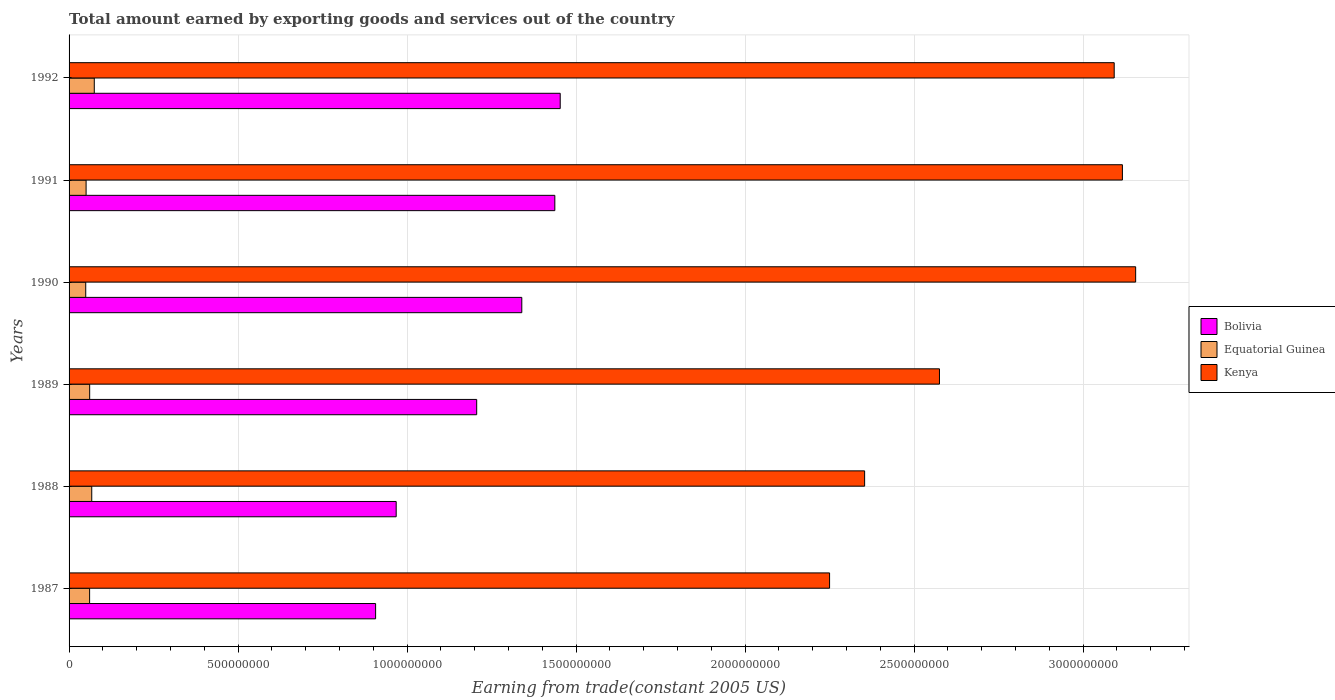Are the number of bars per tick equal to the number of legend labels?
Your response must be concise. Yes. In how many cases, is the number of bars for a given year not equal to the number of legend labels?
Give a very brief answer. 0. What is the total amount earned by exporting goods and services in Kenya in 1992?
Ensure brevity in your answer.  3.09e+09. Across all years, what is the maximum total amount earned by exporting goods and services in Kenya?
Your answer should be compact. 3.16e+09. Across all years, what is the minimum total amount earned by exporting goods and services in Bolivia?
Make the answer very short. 9.07e+08. In which year was the total amount earned by exporting goods and services in Bolivia maximum?
Offer a terse response. 1992. What is the total total amount earned by exporting goods and services in Kenya in the graph?
Provide a short and direct response. 1.65e+1. What is the difference between the total amount earned by exporting goods and services in Equatorial Guinea in 1988 and that in 1989?
Provide a short and direct response. 6.15e+06. What is the difference between the total amount earned by exporting goods and services in Bolivia in 1991 and the total amount earned by exporting goods and services in Kenya in 1989?
Make the answer very short. -1.14e+09. What is the average total amount earned by exporting goods and services in Kenya per year?
Make the answer very short. 2.76e+09. In the year 1991, what is the difference between the total amount earned by exporting goods and services in Bolivia and total amount earned by exporting goods and services in Kenya?
Your answer should be compact. -1.68e+09. What is the ratio of the total amount earned by exporting goods and services in Bolivia in 1987 to that in 1988?
Offer a very short reply. 0.94. Is the total amount earned by exporting goods and services in Kenya in 1989 less than that in 1992?
Offer a terse response. Yes. Is the difference between the total amount earned by exporting goods and services in Bolivia in 1988 and 1990 greater than the difference between the total amount earned by exporting goods and services in Kenya in 1988 and 1990?
Your response must be concise. Yes. What is the difference between the highest and the second highest total amount earned by exporting goods and services in Bolivia?
Provide a succinct answer. 1.60e+07. What is the difference between the highest and the lowest total amount earned by exporting goods and services in Kenya?
Keep it short and to the point. 9.06e+08. Is the sum of the total amount earned by exporting goods and services in Bolivia in 1988 and 1991 greater than the maximum total amount earned by exporting goods and services in Kenya across all years?
Give a very brief answer. No. What does the 1st bar from the top in 1991 represents?
Keep it short and to the point. Kenya. What does the 2nd bar from the bottom in 1992 represents?
Give a very brief answer. Equatorial Guinea. Is it the case that in every year, the sum of the total amount earned by exporting goods and services in Equatorial Guinea and total amount earned by exporting goods and services in Bolivia is greater than the total amount earned by exporting goods and services in Kenya?
Make the answer very short. No. How many bars are there?
Your answer should be very brief. 18. Are all the bars in the graph horizontal?
Keep it short and to the point. Yes. What is the difference between two consecutive major ticks on the X-axis?
Ensure brevity in your answer.  5.00e+08. Does the graph contain any zero values?
Your response must be concise. No. How many legend labels are there?
Keep it short and to the point. 3. What is the title of the graph?
Provide a short and direct response. Total amount earned by exporting goods and services out of the country. What is the label or title of the X-axis?
Your answer should be very brief. Earning from trade(constant 2005 US). What is the label or title of the Y-axis?
Offer a very short reply. Years. What is the Earning from trade(constant 2005 US) in Bolivia in 1987?
Ensure brevity in your answer.  9.07e+08. What is the Earning from trade(constant 2005 US) of Equatorial Guinea in 1987?
Make the answer very short. 6.08e+07. What is the Earning from trade(constant 2005 US) in Kenya in 1987?
Your answer should be compact. 2.25e+09. What is the Earning from trade(constant 2005 US) of Bolivia in 1988?
Make the answer very short. 9.68e+08. What is the Earning from trade(constant 2005 US) in Equatorial Guinea in 1988?
Ensure brevity in your answer.  6.71e+07. What is the Earning from trade(constant 2005 US) in Kenya in 1988?
Your answer should be very brief. 2.35e+09. What is the Earning from trade(constant 2005 US) of Bolivia in 1989?
Ensure brevity in your answer.  1.21e+09. What is the Earning from trade(constant 2005 US) of Equatorial Guinea in 1989?
Your response must be concise. 6.09e+07. What is the Earning from trade(constant 2005 US) of Kenya in 1989?
Give a very brief answer. 2.58e+09. What is the Earning from trade(constant 2005 US) of Bolivia in 1990?
Offer a very short reply. 1.34e+09. What is the Earning from trade(constant 2005 US) of Equatorial Guinea in 1990?
Offer a very short reply. 4.93e+07. What is the Earning from trade(constant 2005 US) in Kenya in 1990?
Offer a terse response. 3.16e+09. What is the Earning from trade(constant 2005 US) in Bolivia in 1991?
Ensure brevity in your answer.  1.44e+09. What is the Earning from trade(constant 2005 US) of Equatorial Guinea in 1991?
Ensure brevity in your answer.  5.03e+07. What is the Earning from trade(constant 2005 US) in Kenya in 1991?
Your answer should be very brief. 3.12e+09. What is the Earning from trade(constant 2005 US) of Bolivia in 1992?
Provide a succinct answer. 1.45e+09. What is the Earning from trade(constant 2005 US) of Equatorial Guinea in 1992?
Your answer should be compact. 7.46e+07. What is the Earning from trade(constant 2005 US) in Kenya in 1992?
Your answer should be very brief. 3.09e+09. Across all years, what is the maximum Earning from trade(constant 2005 US) of Bolivia?
Ensure brevity in your answer.  1.45e+09. Across all years, what is the maximum Earning from trade(constant 2005 US) of Equatorial Guinea?
Your answer should be compact. 7.46e+07. Across all years, what is the maximum Earning from trade(constant 2005 US) in Kenya?
Provide a succinct answer. 3.16e+09. Across all years, what is the minimum Earning from trade(constant 2005 US) of Bolivia?
Give a very brief answer. 9.07e+08. Across all years, what is the minimum Earning from trade(constant 2005 US) in Equatorial Guinea?
Offer a terse response. 4.93e+07. Across all years, what is the minimum Earning from trade(constant 2005 US) in Kenya?
Your response must be concise. 2.25e+09. What is the total Earning from trade(constant 2005 US) of Bolivia in the graph?
Offer a terse response. 7.31e+09. What is the total Earning from trade(constant 2005 US) of Equatorial Guinea in the graph?
Your answer should be very brief. 3.63e+08. What is the total Earning from trade(constant 2005 US) of Kenya in the graph?
Provide a succinct answer. 1.65e+1. What is the difference between the Earning from trade(constant 2005 US) in Bolivia in 1987 and that in 1988?
Ensure brevity in your answer.  -6.08e+07. What is the difference between the Earning from trade(constant 2005 US) of Equatorial Guinea in 1987 and that in 1988?
Make the answer very short. -6.31e+06. What is the difference between the Earning from trade(constant 2005 US) in Kenya in 1987 and that in 1988?
Keep it short and to the point. -1.04e+08. What is the difference between the Earning from trade(constant 2005 US) of Bolivia in 1987 and that in 1989?
Your answer should be very brief. -2.99e+08. What is the difference between the Earning from trade(constant 2005 US) in Equatorial Guinea in 1987 and that in 1989?
Offer a terse response. -1.62e+05. What is the difference between the Earning from trade(constant 2005 US) of Kenya in 1987 and that in 1989?
Provide a succinct answer. -3.25e+08. What is the difference between the Earning from trade(constant 2005 US) in Bolivia in 1987 and that in 1990?
Make the answer very short. -4.33e+08. What is the difference between the Earning from trade(constant 2005 US) in Equatorial Guinea in 1987 and that in 1990?
Keep it short and to the point. 1.15e+07. What is the difference between the Earning from trade(constant 2005 US) of Kenya in 1987 and that in 1990?
Your answer should be compact. -9.06e+08. What is the difference between the Earning from trade(constant 2005 US) of Bolivia in 1987 and that in 1991?
Your response must be concise. -5.30e+08. What is the difference between the Earning from trade(constant 2005 US) of Equatorial Guinea in 1987 and that in 1991?
Make the answer very short. 1.04e+07. What is the difference between the Earning from trade(constant 2005 US) in Kenya in 1987 and that in 1991?
Ensure brevity in your answer.  -8.66e+08. What is the difference between the Earning from trade(constant 2005 US) in Bolivia in 1987 and that in 1992?
Ensure brevity in your answer.  -5.46e+08. What is the difference between the Earning from trade(constant 2005 US) in Equatorial Guinea in 1987 and that in 1992?
Offer a very short reply. -1.38e+07. What is the difference between the Earning from trade(constant 2005 US) in Kenya in 1987 and that in 1992?
Your response must be concise. -8.42e+08. What is the difference between the Earning from trade(constant 2005 US) in Bolivia in 1988 and that in 1989?
Your response must be concise. -2.38e+08. What is the difference between the Earning from trade(constant 2005 US) in Equatorial Guinea in 1988 and that in 1989?
Give a very brief answer. 6.15e+06. What is the difference between the Earning from trade(constant 2005 US) of Kenya in 1988 and that in 1989?
Provide a short and direct response. -2.21e+08. What is the difference between the Earning from trade(constant 2005 US) in Bolivia in 1988 and that in 1990?
Provide a short and direct response. -3.72e+08. What is the difference between the Earning from trade(constant 2005 US) of Equatorial Guinea in 1988 and that in 1990?
Provide a succinct answer. 1.78e+07. What is the difference between the Earning from trade(constant 2005 US) in Kenya in 1988 and that in 1990?
Your answer should be very brief. -8.02e+08. What is the difference between the Earning from trade(constant 2005 US) in Bolivia in 1988 and that in 1991?
Give a very brief answer. -4.69e+08. What is the difference between the Earning from trade(constant 2005 US) of Equatorial Guinea in 1988 and that in 1991?
Give a very brief answer. 1.67e+07. What is the difference between the Earning from trade(constant 2005 US) in Kenya in 1988 and that in 1991?
Offer a very short reply. -7.63e+08. What is the difference between the Earning from trade(constant 2005 US) of Bolivia in 1988 and that in 1992?
Provide a succinct answer. -4.85e+08. What is the difference between the Earning from trade(constant 2005 US) in Equatorial Guinea in 1988 and that in 1992?
Offer a terse response. -7.53e+06. What is the difference between the Earning from trade(constant 2005 US) in Kenya in 1988 and that in 1992?
Ensure brevity in your answer.  -7.38e+08. What is the difference between the Earning from trade(constant 2005 US) in Bolivia in 1989 and that in 1990?
Your answer should be compact. -1.33e+08. What is the difference between the Earning from trade(constant 2005 US) in Equatorial Guinea in 1989 and that in 1990?
Your answer should be very brief. 1.16e+07. What is the difference between the Earning from trade(constant 2005 US) in Kenya in 1989 and that in 1990?
Your answer should be very brief. -5.80e+08. What is the difference between the Earning from trade(constant 2005 US) of Bolivia in 1989 and that in 1991?
Offer a very short reply. -2.31e+08. What is the difference between the Earning from trade(constant 2005 US) in Equatorial Guinea in 1989 and that in 1991?
Your answer should be very brief. 1.06e+07. What is the difference between the Earning from trade(constant 2005 US) in Kenya in 1989 and that in 1991?
Make the answer very short. -5.41e+08. What is the difference between the Earning from trade(constant 2005 US) of Bolivia in 1989 and that in 1992?
Keep it short and to the point. -2.47e+08. What is the difference between the Earning from trade(constant 2005 US) of Equatorial Guinea in 1989 and that in 1992?
Give a very brief answer. -1.37e+07. What is the difference between the Earning from trade(constant 2005 US) of Kenya in 1989 and that in 1992?
Offer a terse response. -5.17e+08. What is the difference between the Earning from trade(constant 2005 US) of Bolivia in 1990 and that in 1991?
Keep it short and to the point. -9.77e+07. What is the difference between the Earning from trade(constant 2005 US) of Equatorial Guinea in 1990 and that in 1991?
Offer a terse response. -1.04e+06. What is the difference between the Earning from trade(constant 2005 US) in Kenya in 1990 and that in 1991?
Your response must be concise. 3.92e+07. What is the difference between the Earning from trade(constant 2005 US) in Bolivia in 1990 and that in 1992?
Offer a very short reply. -1.14e+08. What is the difference between the Earning from trade(constant 2005 US) of Equatorial Guinea in 1990 and that in 1992?
Offer a terse response. -2.53e+07. What is the difference between the Earning from trade(constant 2005 US) of Kenya in 1990 and that in 1992?
Offer a terse response. 6.35e+07. What is the difference between the Earning from trade(constant 2005 US) in Bolivia in 1991 and that in 1992?
Provide a succinct answer. -1.60e+07. What is the difference between the Earning from trade(constant 2005 US) of Equatorial Guinea in 1991 and that in 1992?
Your response must be concise. -2.43e+07. What is the difference between the Earning from trade(constant 2005 US) in Kenya in 1991 and that in 1992?
Your answer should be very brief. 2.43e+07. What is the difference between the Earning from trade(constant 2005 US) of Bolivia in 1987 and the Earning from trade(constant 2005 US) of Equatorial Guinea in 1988?
Provide a short and direct response. 8.40e+08. What is the difference between the Earning from trade(constant 2005 US) of Bolivia in 1987 and the Earning from trade(constant 2005 US) of Kenya in 1988?
Make the answer very short. -1.45e+09. What is the difference between the Earning from trade(constant 2005 US) in Equatorial Guinea in 1987 and the Earning from trade(constant 2005 US) in Kenya in 1988?
Your response must be concise. -2.29e+09. What is the difference between the Earning from trade(constant 2005 US) in Bolivia in 1987 and the Earning from trade(constant 2005 US) in Equatorial Guinea in 1989?
Your answer should be compact. 8.46e+08. What is the difference between the Earning from trade(constant 2005 US) of Bolivia in 1987 and the Earning from trade(constant 2005 US) of Kenya in 1989?
Your answer should be compact. -1.67e+09. What is the difference between the Earning from trade(constant 2005 US) in Equatorial Guinea in 1987 and the Earning from trade(constant 2005 US) in Kenya in 1989?
Your response must be concise. -2.51e+09. What is the difference between the Earning from trade(constant 2005 US) of Bolivia in 1987 and the Earning from trade(constant 2005 US) of Equatorial Guinea in 1990?
Give a very brief answer. 8.58e+08. What is the difference between the Earning from trade(constant 2005 US) in Bolivia in 1987 and the Earning from trade(constant 2005 US) in Kenya in 1990?
Provide a succinct answer. -2.25e+09. What is the difference between the Earning from trade(constant 2005 US) of Equatorial Guinea in 1987 and the Earning from trade(constant 2005 US) of Kenya in 1990?
Your answer should be very brief. -3.09e+09. What is the difference between the Earning from trade(constant 2005 US) in Bolivia in 1987 and the Earning from trade(constant 2005 US) in Equatorial Guinea in 1991?
Your answer should be compact. 8.57e+08. What is the difference between the Earning from trade(constant 2005 US) in Bolivia in 1987 and the Earning from trade(constant 2005 US) in Kenya in 1991?
Your answer should be compact. -2.21e+09. What is the difference between the Earning from trade(constant 2005 US) in Equatorial Guinea in 1987 and the Earning from trade(constant 2005 US) in Kenya in 1991?
Your answer should be very brief. -3.06e+09. What is the difference between the Earning from trade(constant 2005 US) of Bolivia in 1987 and the Earning from trade(constant 2005 US) of Equatorial Guinea in 1992?
Offer a terse response. 8.32e+08. What is the difference between the Earning from trade(constant 2005 US) in Bolivia in 1987 and the Earning from trade(constant 2005 US) in Kenya in 1992?
Offer a terse response. -2.19e+09. What is the difference between the Earning from trade(constant 2005 US) in Equatorial Guinea in 1987 and the Earning from trade(constant 2005 US) in Kenya in 1992?
Offer a terse response. -3.03e+09. What is the difference between the Earning from trade(constant 2005 US) of Bolivia in 1988 and the Earning from trade(constant 2005 US) of Equatorial Guinea in 1989?
Provide a short and direct response. 9.07e+08. What is the difference between the Earning from trade(constant 2005 US) of Bolivia in 1988 and the Earning from trade(constant 2005 US) of Kenya in 1989?
Your answer should be very brief. -1.61e+09. What is the difference between the Earning from trade(constant 2005 US) of Equatorial Guinea in 1988 and the Earning from trade(constant 2005 US) of Kenya in 1989?
Provide a short and direct response. -2.51e+09. What is the difference between the Earning from trade(constant 2005 US) in Bolivia in 1988 and the Earning from trade(constant 2005 US) in Equatorial Guinea in 1990?
Give a very brief answer. 9.18e+08. What is the difference between the Earning from trade(constant 2005 US) of Bolivia in 1988 and the Earning from trade(constant 2005 US) of Kenya in 1990?
Your answer should be compact. -2.19e+09. What is the difference between the Earning from trade(constant 2005 US) of Equatorial Guinea in 1988 and the Earning from trade(constant 2005 US) of Kenya in 1990?
Provide a short and direct response. -3.09e+09. What is the difference between the Earning from trade(constant 2005 US) in Bolivia in 1988 and the Earning from trade(constant 2005 US) in Equatorial Guinea in 1991?
Your response must be concise. 9.17e+08. What is the difference between the Earning from trade(constant 2005 US) of Bolivia in 1988 and the Earning from trade(constant 2005 US) of Kenya in 1991?
Your answer should be compact. -2.15e+09. What is the difference between the Earning from trade(constant 2005 US) of Equatorial Guinea in 1988 and the Earning from trade(constant 2005 US) of Kenya in 1991?
Provide a short and direct response. -3.05e+09. What is the difference between the Earning from trade(constant 2005 US) of Bolivia in 1988 and the Earning from trade(constant 2005 US) of Equatorial Guinea in 1992?
Provide a succinct answer. 8.93e+08. What is the difference between the Earning from trade(constant 2005 US) in Bolivia in 1988 and the Earning from trade(constant 2005 US) in Kenya in 1992?
Keep it short and to the point. -2.12e+09. What is the difference between the Earning from trade(constant 2005 US) in Equatorial Guinea in 1988 and the Earning from trade(constant 2005 US) in Kenya in 1992?
Your response must be concise. -3.03e+09. What is the difference between the Earning from trade(constant 2005 US) in Bolivia in 1989 and the Earning from trade(constant 2005 US) in Equatorial Guinea in 1990?
Offer a terse response. 1.16e+09. What is the difference between the Earning from trade(constant 2005 US) of Bolivia in 1989 and the Earning from trade(constant 2005 US) of Kenya in 1990?
Your answer should be very brief. -1.95e+09. What is the difference between the Earning from trade(constant 2005 US) in Equatorial Guinea in 1989 and the Earning from trade(constant 2005 US) in Kenya in 1990?
Provide a short and direct response. -3.09e+09. What is the difference between the Earning from trade(constant 2005 US) of Bolivia in 1989 and the Earning from trade(constant 2005 US) of Equatorial Guinea in 1991?
Provide a short and direct response. 1.16e+09. What is the difference between the Earning from trade(constant 2005 US) of Bolivia in 1989 and the Earning from trade(constant 2005 US) of Kenya in 1991?
Give a very brief answer. -1.91e+09. What is the difference between the Earning from trade(constant 2005 US) in Equatorial Guinea in 1989 and the Earning from trade(constant 2005 US) in Kenya in 1991?
Ensure brevity in your answer.  -3.06e+09. What is the difference between the Earning from trade(constant 2005 US) in Bolivia in 1989 and the Earning from trade(constant 2005 US) in Equatorial Guinea in 1992?
Keep it short and to the point. 1.13e+09. What is the difference between the Earning from trade(constant 2005 US) in Bolivia in 1989 and the Earning from trade(constant 2005 US) in Kenya in 1992?
Provide a succinct answer. -1.89e+09. What is the difference between the Earning from trade(constant 2005 US) in Equatorial Guinea in 1989 and the Earning from trade(constant 2005 US) in Kenya in 1992?
Your answer should be very brief. -3.03e+09. What is the difference between the Earning from trade(constant 2005 US) in Bolivia in 1990 and the Earning from trade(constant 2005 US) in Equatorial Guinea in 1991?
Offer a terse response. 1.29e+09. What is the difference between the Earning from trade(constant 2005 US) in Bolivia in 1990 and the Earning from trade(constant 2005 US) in Kenya in 1991?
Your answer should be compact. -1.78e+09. What is the difference between the Earning from trade(constant 2005 US) in Equatorial Guinea in 1990 and the Earning from trade(constant 2005 US) in Kenya in 1991?
Your answer should be very brief. -3.07e+09. What is the difference between the Earning from trade(constant 2005 US) of Bolivia in 1990 and the Earning from trade(constant 2005 US) of Equatorial Guinea in 1992?
Make the answer very short. 1.26e+09. What is the difference between the Earning from trade(constant 2005 US) of Bolivia in 1990 and the Earning from trade(constant 2005 US) of Kenya in 1992?
Provide a succinct answer. -1.75e+09. What is the difference between the Earning from trade(constant 2005 US) of Equatorial Guinea in 1990 and the Earning from trade(constant 2005 US) of Kenya in 1992?
Keep it short and to the point. -3.04e+09. What is the difference between the Earning from trade(constant 2005 US) of Bolivia in 1991 and the Earning from trade(constant 2005 US) of Equatorial Guinea in 1992?
Your answer should be very brief. 1.36e+09. What is the difference between the Earning from trade(constant 2005 US) of Bolivia in 1991 and the Earning from trade(constant 2005 US) of Kenya in 1992?
Keep it short and to the point. -1.65e+09. What is the difference between the Earning from trade(constant 2005 US) in Equatorial Guinea in 1991 and the Earning from trade(constant 2005 US) in Kenya in 1992?
Your answer should be very brief. -3.04e+09. What is the average Earning from trade(constant 2005 US) in Bolivia per year?
Provide a succinct answer. 1.22e+09. What is the average Earning from trade(constant 2005 US) of Equatorial Guinea per year?
Provide a short and direct response. 6.05e+07. What is the average Earning from trade(constant 2005 US) of Kenya per year?
Your response must be concise. 2.76e+09. In the year 1987, what is the difference between the Earning from trade(constant 2005 US) of Bolivia and Earning from trade(constant 2005 US) of Equatorial Guinea?
Provide a short and direct response. 8.46e+08. In the year 1987, what is the difference between the Earning from trade(constant 2005 US) in Bolivia and Earning from trade(constant 2005 US) in Kenya?
Make the answer very short. -1.34e+09. In the year 1987, what is the difference between the Earning from trade(constant 2005 US) of Equatorial Guinea and Earning from trade(constant 2005 US) of Kenya?
Keep it short and to the point. -2.19e+09. In the year 1988, what is the difference between the Earning from trade(constant 2005 US) in Bolivia and Earning from trade(constant 2005 US) in Equatorial Guinea?
Offer a very short reply. 9.01e+08. In the year 1988, what is the difference between the Earning from trade(constant 2005 US) in Bolivia and Earning from trade(constant 2005 US) in Kenya?
Ensure brevity in your answer.  -1.39e+09. In the year 1988, what is the difference between the Earning from trade(constant 2005 US) of Equatorial Guinea and Earning from trade(constant 2005 US) of Kenya?
Offer a terse response. -2.29e+09. In the year 1989, what is the difference between the Earning from trade(constant 2005 US) of Bolivia and Earning from trade(constant 2005 US) of Equatorial Guinea?
Provide a short and direct response. 1.15e+09. In the year 1989, what is the difference between the Earning from trade(constant 2005 US) in Bolivia and Earning from trade(constant 2005 US) in Kenya?
Keep it short and to the point. -1.37e+09. In the year 1989, what is the difference between the Earning from trade(constant 2005 US) in Equatorial Guinea and Earning from trade(constant 2005 US) in Kenya?
Offer a very short reply. -2.51e+09. In the year 1990, what is the difference between the Earning from trade(constant 2005 US) in Bolivia and Earning from trade(constant 2005 US) in Equatorial Guinea?
Give a very brief answer. 1.29e+09. In the year 1990, what is the difference between the Earning from trade(constant 2005 US) in Bolivia and Earning from trade(constant 2005 US) in Kenya?
Ensure brevity in your answer.  -1.82e+09. In the year 1990, what is the difference between the Earning from trade(constant 2005 US) of Equatorial Guinea and Earning from trade(constant 2005 US) of Kenya?
Provide a succinct answer. -3.11e+09. In the year 1991, what is the difference between the Earning from trade(constant 2005 US) of Bolivia and Earning from trade(constant 2005 US) of Equatorial Guinea?
Offer a terse response. 1.39e+09. In the year 1991, what is the difference between the Earning from trade(constant 2005 US) in Bolivia and Earning from trade(constant 2005 US) in Kenya?
Give a very brief answer. -1.68e+09. In the year 1991, what is the difference between the Earning from trade(constant 2005 US) in Equatorial Guinea and Earning from trade(constant 2005 US) in Kenya?
Your response must be concise. -3.07e+09. In the year 1992, what is the difference between the Earning from trade(constant 2005 US) in Bolivia and Earning from trade(constant 2005 US) in Equatorial Guinea?
Provide a short and direct response. 1.38e+09. In the year 1992, what is the difference between the Earning from trade(constant 2005 US) in Bolivia and Earning from trade(constant 2005 US) in Kenya?
Offer a very short reply. -1.64e+09. In the year 1992, what is the difference between the Earning from trade(constant 2005 US) in Equatorial Guinea and Earning from trade(constant 2005 US) in Kenya?
Your response must be concise. -3.02e+09. What is the ratio of the Earning from trade(constant 2005 US) in Bolivia in 1987 to that in 1988?
Ensure brevity in your answer.  0.94. What is the ratio of the Earning from trade(constant 2005 US) in Equatorial Guinea in 1987 to that in 1988?
Your response must be concise. 0.91. What is the ratio of the Earning from trade(constant 2005 US) of Kenya in 1987 to that in 1988?
Ensure brevity in your answer.  0.96. What is the ratio of the Earning from trade(constant 2005 US) in Bolivia in 1987 to that in 1989?
Your answer should be very brief. 0.75. What is the ratio of the Earning from trade(constant 2005 US) in Kenya in 1987 to that in 1989?
Offer a terse response. 0.87. What is the ratio of the Earning from trade(constant 2005 US) of Bolivia in 1987 to that in 1990?
Your answer should be very brief. 0.68. What is the ratio of the Earning from trade(constant 2005 US) in Equatorial Guinea in 1987 to that in 1990?
Offer a terse response. 1.23. What is the ratio of the Earning from trade(constant 2005 US) of Kenya in 1987 to that in 1990?
Provide a succinct answer. 0.71. What is the ratio of the Earning from trade(constant 2005 US) of Bolivia in 1987 to that in 1991?
Your answer should be very brief. 0.63. What is the ratio of the Earning from trade(constant 2005 US) in Equatorial Guinea in 1987 to that in 1991?
Make the answer very short. 1.21. What is the ratio of the Earning from trade(constant 2005 US) of Kenya in 1987 to that in 1991?
Provide a succinct answer. 0.72. What is the ratio of the Earning from trade(constant 2005 US) of Bolivia in 1987 to that in 1992?
Provide a succinct answer. 0.62. What is the ratio of the Earning from trade(constant 2005 US) of Equatorial Guinea in 1987 to that in 1992?
Give a very brief answer. 0.81. What is the ratio of the Earning from trade(constant 2005 US) in Kenya in 1987 to that in 1992?
Offer a very short reply. 0.73. What is the ratio of the Earning from trade(constant 2005 US) in Bolivia in 1988 to that in 1989?
Offer a very short reply. 0.8. What is the ratio of the Earning from trade(constant 2005 US) in Equatorial Guinea in 1988 to that in 1989?
Give a very brief answer. 1.1. What is the ratio of the Earning from trade(constant 2005 US) in Kenya in 1988 to that in 1989?
Provide a succinct answer. 0.91. What is the ratio of the Earning from trade(constant 2005 US) of Bolivia in 1988 to that in 1990?
Ensure brevity in your answer.  0.72. What is the ratio of the Earning from trade(constant 2005 US) of Equatorial Guinea in 1988 to that in 1990?
Provide a succinct answer. 1.36. What is the ratio of the Earning from trade(constant 2005 US) of Kenya in 1988 to that in 1990?
Your answer should be compact. 0.75. What is the ratio of the Earning from trade(constant 2005 US) of Bolivia in 1988 to that in 1991?
Offer a very short reply. 0.67. What is the ratio of the Earning from trade(constant 2005 US) of Equatorial Guinea in 1988 to that in 1991?
Your response must be concise. 1.33. What is the ratio of the Earning from trade(constant 2005 US) of Kenya in 1988 to that in 1991?
Make the answer very short. 0.76. What is the ratio of the Earning from trade(constant 2005 US) in Bolivia in 1988 to that in 1992?
Offer a terse response. 0.67. What is the ratio of the Earning from trade(constant 2005 US) in Equatorial Guinea in 1988 to that in 1992?
Your response must be concise. 0.9. What is the ratio of the Earning from trade(constant 2005 US) of Kenya in 1988 to that in 1992?
Give a very brief answer. 0.76. What is the ratio of the Earning from trade(constant 2005 US) in Bolivia in 1989 to that in 1990?
Provide a short and direct response. 0.9. What is the ratio of the Earning from trade(constant 2005 US) in Equatorial Guinea in 1989 to that in 1990?
Ensure brevity in your answer.  1.24. What is the ratio of the Earning from trade(constant 2005 US) in Kenya in 1989 to that in 1990?
Provide a succinct answer. 0.82. What is the ratio of the Earning from trade(constant 2005 US) of Bolivia in 1989 to that in 1991?
Your answer should be very brief. 0.84. What is the ratio of the Earning from trade(constant 2005 US) of Equatorial Guinea in 1989 to that in 1991?
Provide a succinct answer. 1.21. What is the ratio of the Earning from trade(constant 2005 US) in Kenya in 1989 to that in 1991?
Give a very brief answer. 0.83. What is the ratio of the Earning from trade(constant 2005 US) in Bolivia in 1989 to that in 1992?
Keep it short and to the point. 0.83. What is the ratio of the Earning from trade(constant 2005 US) of Equatorial Guinea in 1989 to that in 1992?
Give a very brief answer. 0.82. What is the ratio of the Earning from trade(constant 2005 US) in Kenya in 1989 to that in 1992?
Ensure brevity in your answer.  0.83. What is the ratio of the Earning from trade(constant 2005 US) in Bolivia in 1990 to that in 1991?
Give a very brief answer. 0.93. What is the ratio of the Earning from trade(constant 2005 US) of Equatorial Guinea in 1990 to that in 1991?
Ensure brevity in your answer.  0.98. What is the ratio of the Earning from trade(constant 2005 US) of Kenya in 1990 to that in 1991?
Offer a terse response. 1.01. What is the ratio of the Earning from trade(constant 2005 US) of Bolivia in 1990 to that in 1992?
Offer a terse response. 0.92. What is the ratio of the Earning from trade(constant 2005 US) in Equatorial Guinea in 1990 to that in 1992?
Your answer should be very brief. 0.66. What is the ratio of the Earning from trade(constant 2005 US) of Kenya in 1990 to that in 1992?
Offer a very short reply. 1.02. What is the ratio of the Earning from trade(constant 2005 US) of Bolivia in 1991 to that in 1992?
Offer a very short reply. 0.99. What is the ratio of the Earning from trade(constant 2005 US) in Equatorial Guinea in 1991 to that in 1992?
Offer a very short reply. 0.67. What is the ratio of the Earning from trade(constant 2005 US) of Kenya in 1991 to that in 1992?
Provide a succinct answer. 1.01. What is the difference between the highest and the second highest Earning from trade(constant 2005 US) of Bolivia?
Offer a very short reply. 1.60e+07. What is the difference between the highest and the second highest Earning from trade(constant 2005 US) of Equatorial Guinea?
Give a very brief answer. 7.53e+06. What is the difference between the highest and the second highest Earning from trade(constant 2005 US) in Kenya?
Your response must be concise. 3.92e+07. What is the difference between the highest and the lowest Earning from trade(constant 2005 US) of Bolivia?
Your answer should be compact. 5.46e+08. What is the difference between the highest and the lowest Earning from trade(constant 2005 US) in Equatorial Guinea?
Ensure brevity in your answer.  2.53e+07. What is the difference between the highest and the lowest Earning from trade(constant 2005 US) of Kenya?
Your answer should be compact. 9.06e+08. 